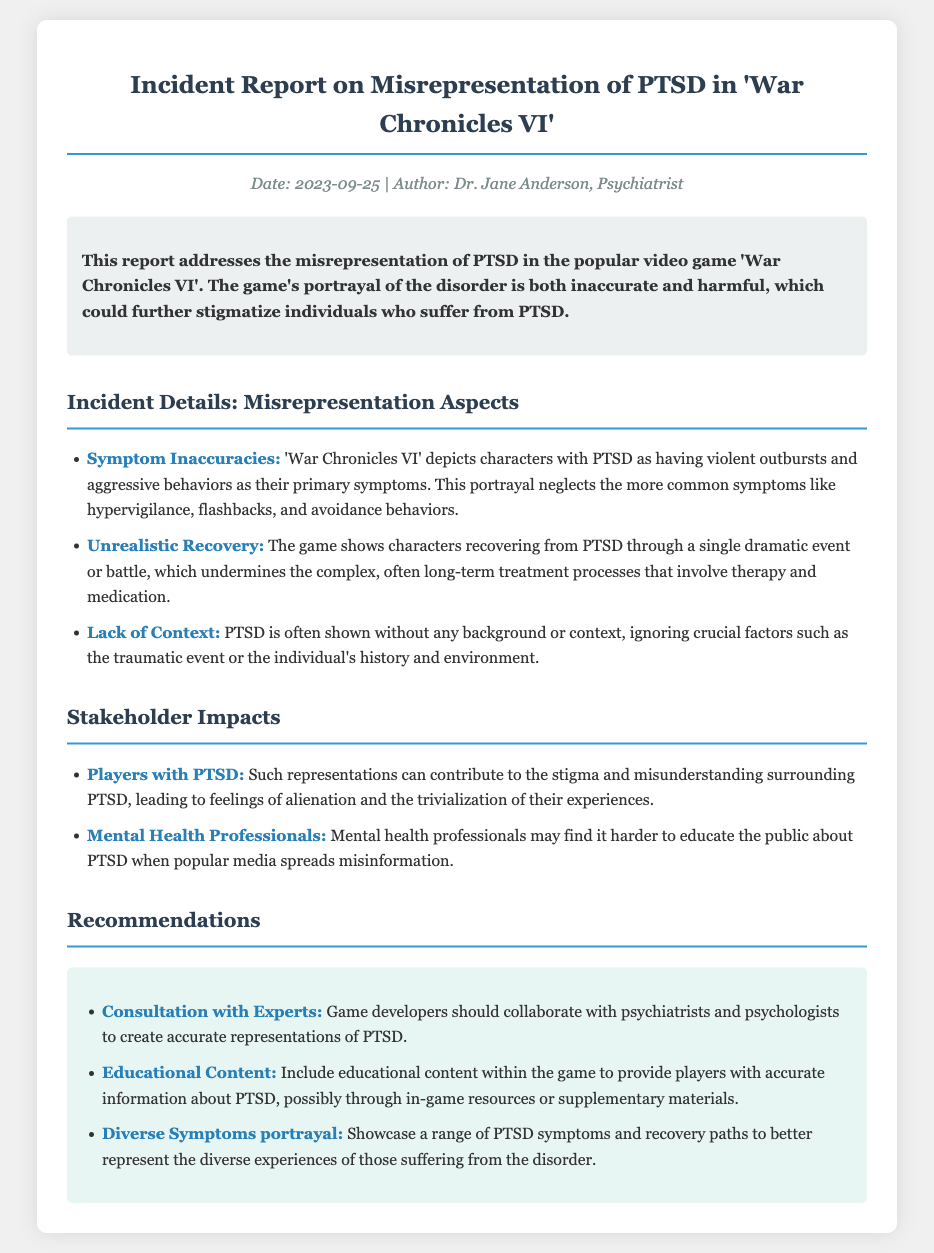What is the date of the report? The date of the report is specified at the top of the document under the meta section.
Answer: 2023-09-25 Who authored the report? The author of the report is mentioned in the meta section.
Answer: Dr. Jane Anderson What is the primary disorder discussed in the report? The primary disorder focused on in the report is highlighted in the summary section.
Answer: PTSD What is one of the aspects of misrepresentation mentioned? The document lists misrepresentation aspects, one of which is specifically highlighted under 'Incident Details'.
Answer: Unrealistic Recovery How can game developers improve their portrayal of PTSD? Recommendations for improvement are provided in a specific section of the document.
Answer: Consultation with Experts What is one impact of misrepresentation on players with PTSD? The document describes a specific impact on this group under the stakeholder impacts section.
Answer: Stigma What percentage of the recommendations focus on educational content? The recommendations section mentions three suggestions, and one is educational, hence it's a third focus area.
Answer: One-third What type of document is this? The document clearly states its purpose in the title and introduction.
Answer: Incident Report 